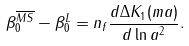Convert formula to latex. <formula><loc_0><loc_0><loc_500><loc_500>\beta _ { 0 } ^ { \overline { M S } } - \beta _ { 0 } ^ { L } = n _ { f } \frac { d \Delta K _ { 1 } ( m a ) } { d \ln a ^ { 2 } } .</formula> 